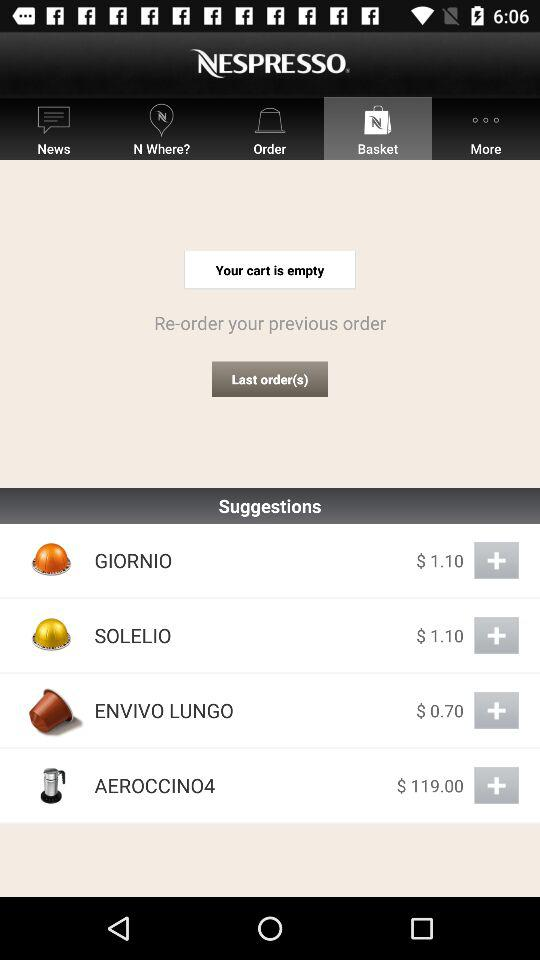Which tab has been selected? The tab that has been selected is "Basket". 